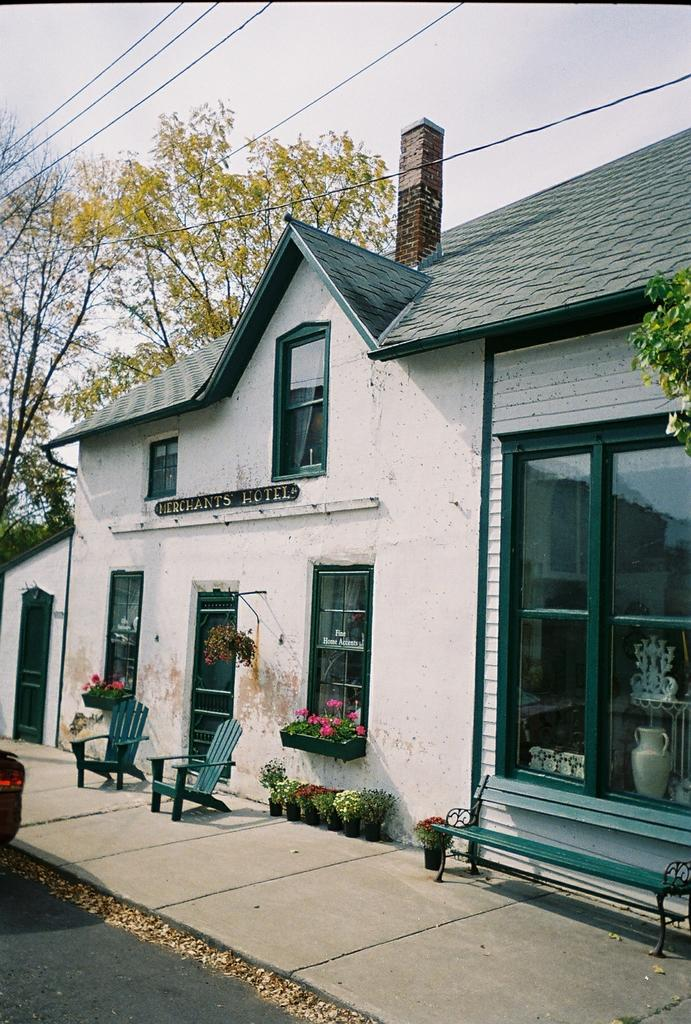What type of structure is present in the image? There is a house in the image. What features can be seen on the house? The house has windows, a door, a roof, and a chimney. What type of furniture is visible in the image? There are chairs and a bench in the image. What other objects can be seen in the image? There is a glass object and a house plant in the image. What is the natural environment like in the image? There are trees in the image, and the sky is visible. Is there any indication of a road in the image? Yes, there is a road in the image. Where is the harbor located in the image? There is no harbor present in the image. What type of knife is being used to cut the house plant in the image? There is no knife present in the image, and the house plant is not being cut. 